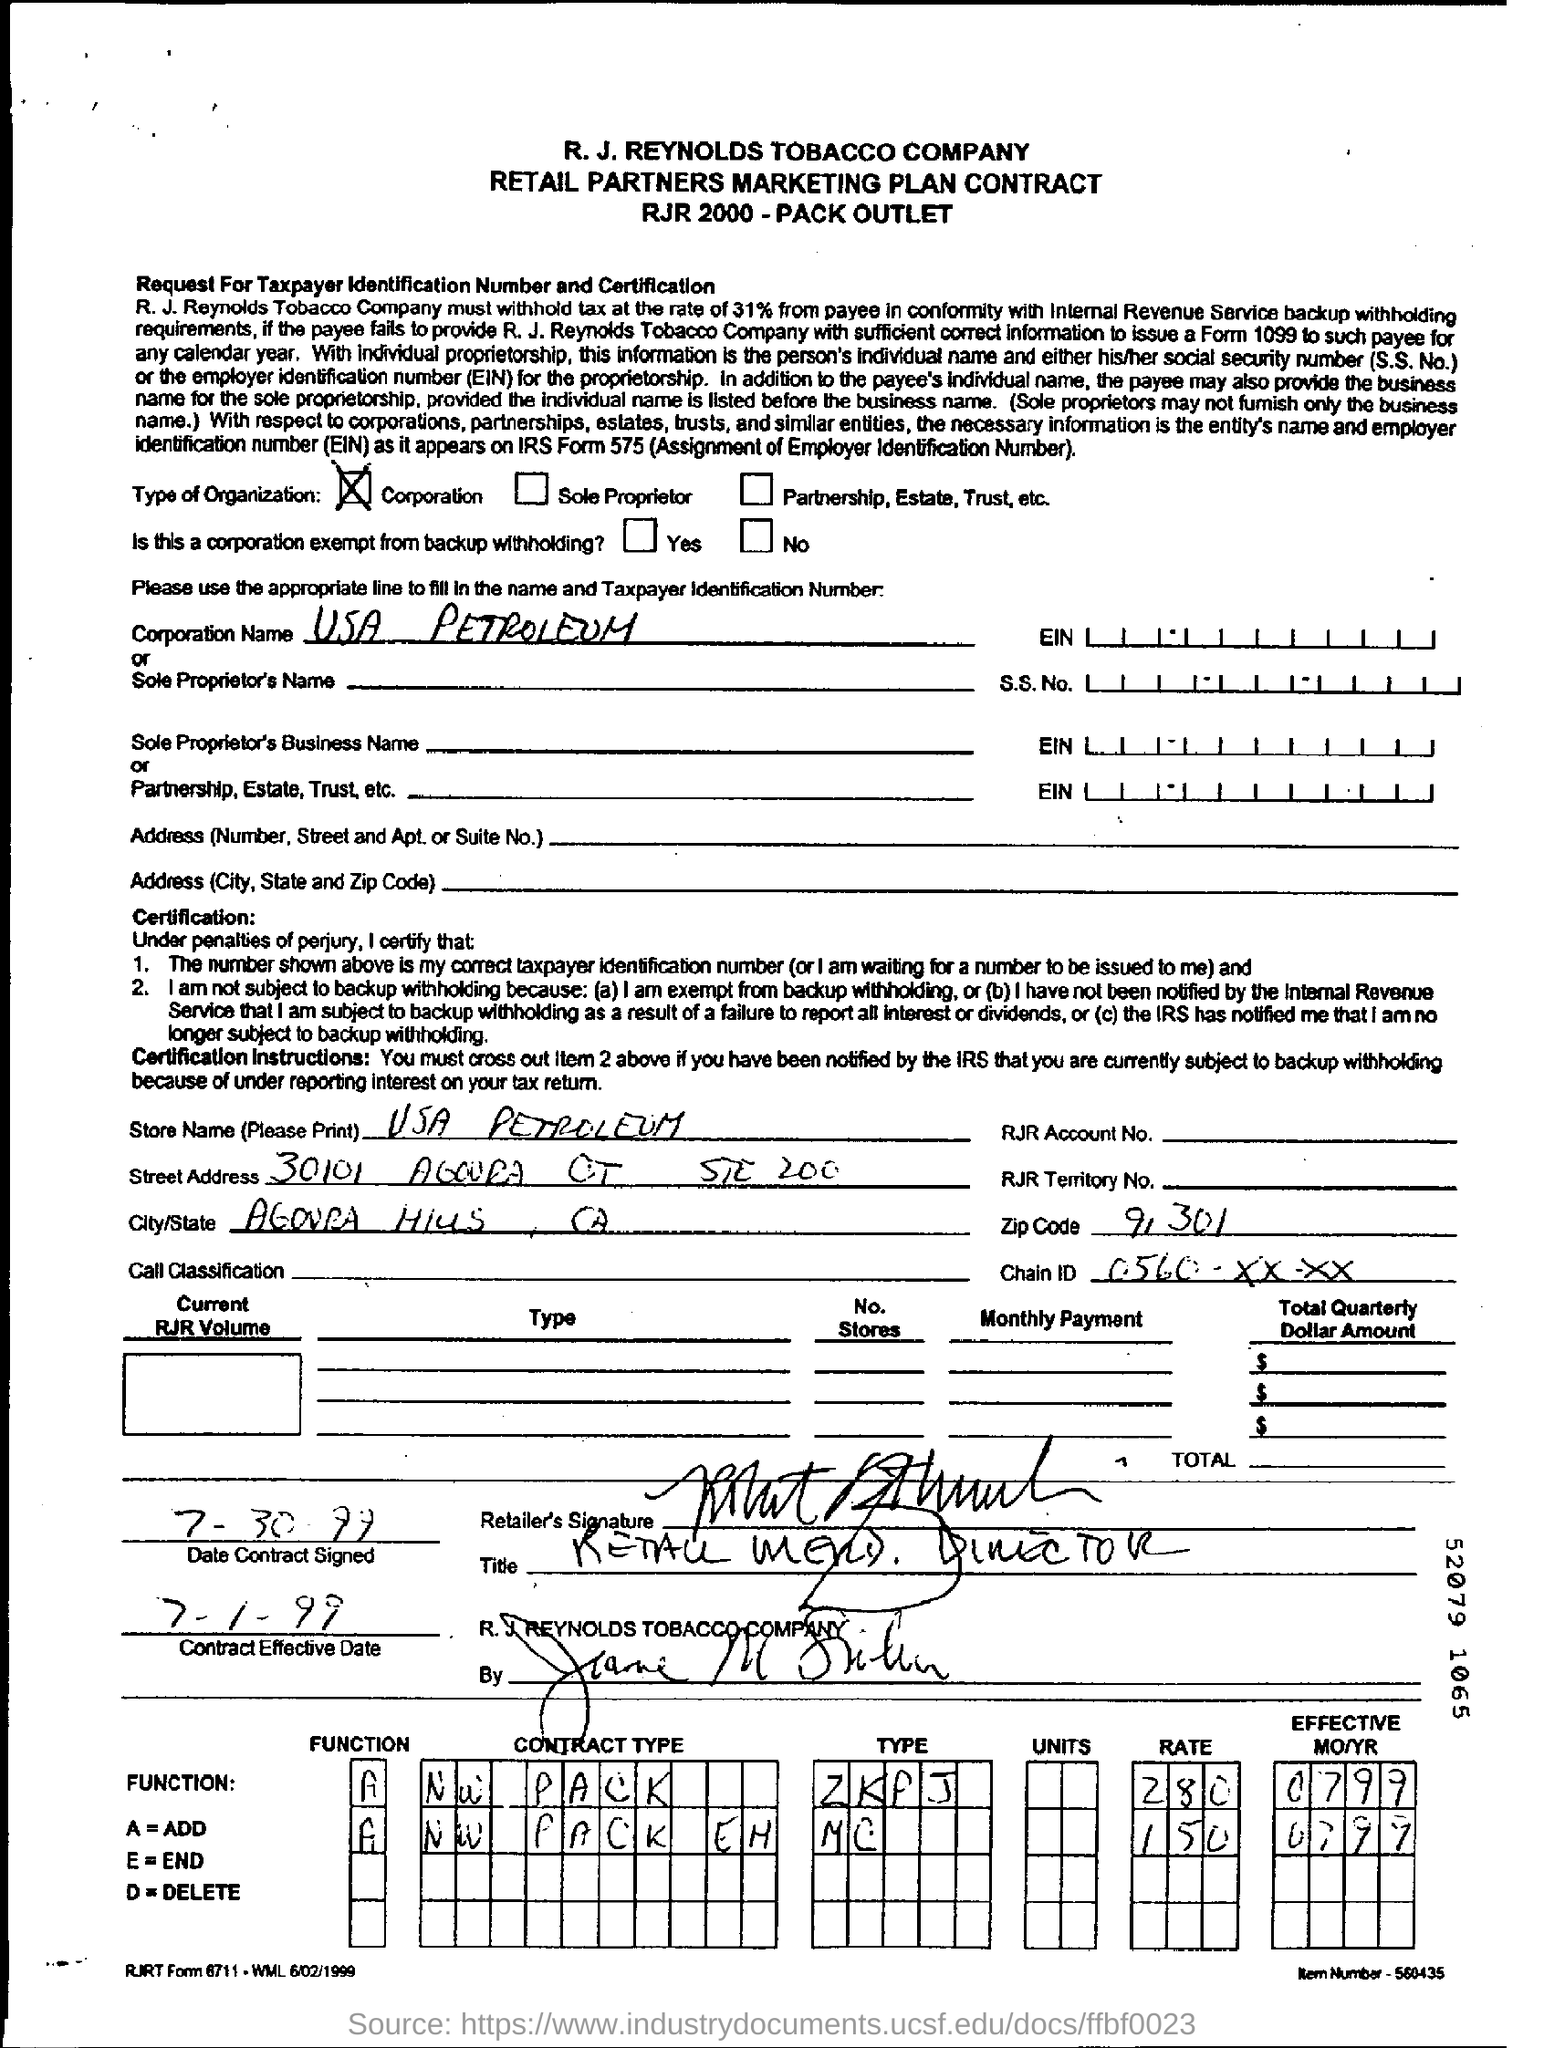Mention a couple of crucial points in this snapshot. The Contract Effective Date is July 1, 1999. The Zip code field contains the number "91301". 